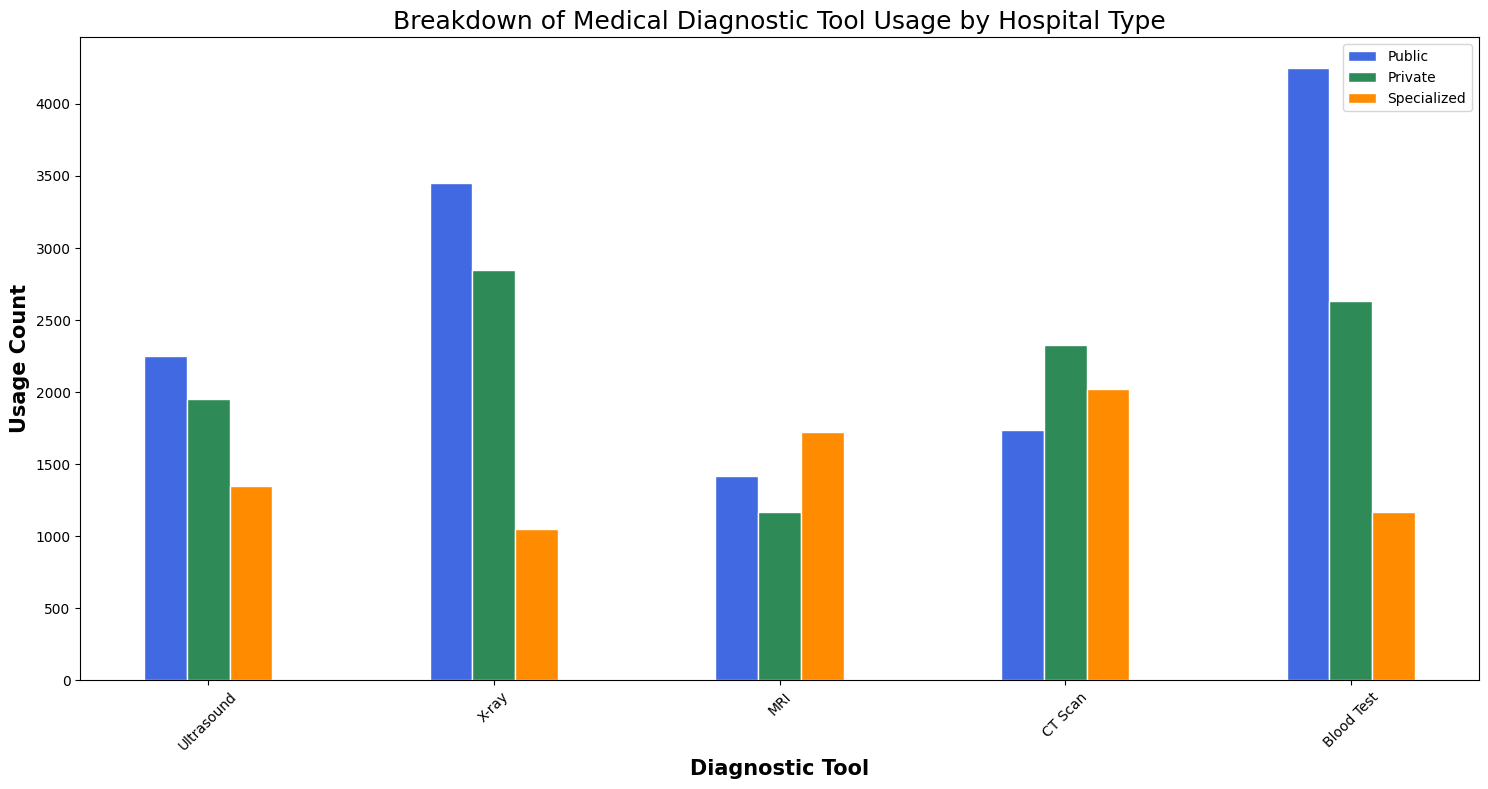Which hospital type has the highest X-ray usage? To find the highest X-ray usage, compare the heights of the X-ray bars for Public, Private, and Specialized hospitals from the chart. The Public hospital's X-ray bar is the tallest.
Answer: Public What's the total MRI usage across all hospital types? Sum the MRI usage of Public, Private, and Specialized hospitals from the figure. Public: 500 + 450 + 470 = 1420, Private: 400 + 350 + 420 = 1170, Specialized: 600 + 550 + 570 = 1720, Total MRI usage: 1420 + 1170 + 1720 = 4310
Answer: 4310 Which diagnostic tool is used the least in Specialized hospitals? Compare the heights of the bars for each diagnostic tool in Specialized hospitals. The Blood Test bar is the shortest.
Answer: Blood Test Is the usage of CT Scan higher in Public or Private hospitals? Compare the heights of the CT Scan bars for Public and Private hospitals. Public: 600 + 550 + 590 = 1740, Private: 800 + 750 + 780 = 2330, Private is higher.
Answer: Private What is the total usage of Blood Tests in Private hospitals? Sum the Blood Test usage from each Private hospital bar in the figure. 900 + 850 + 880 = 2630
Answer: 2630 Compare the usage of ultrasounds in Public and Specialized hospitals. Which is higher? Calculate the total Ultrasound usage for both hospital types. Public Ultrasound: 800 + 700 + 750 = 2250, Specialized Ultrasound: 400 + 450 + 500 = 1350, Public is higher.
Answer: Public What's the average usage of CT Scans across all hospital types? First find the total usage and then average it. Public: 600 + 550 + 590 = 1740, Private: 800 + 750 + 780 = 2330, Specialized: 700 + 650 + 670 = 2020, Total: 1740 + 2330 + 2020 = 6090, Average: 6090 / 3 = 2030
Answer: 2030 